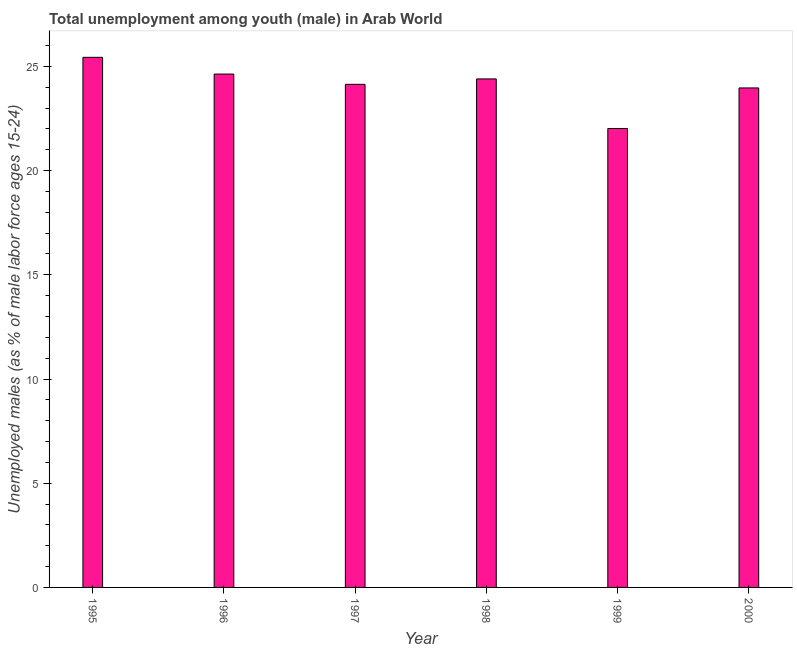What is the title of the graph?
Your response must be concise. Total unemployment among youth (male) in Arab World. What is the label or title of the Y-axis?
Offer a very short reply. Unemployed males (as % of male labor force ages 15-24). What is the unemployed male youth population in 1995?
Provide a short and direct response. 25.44. Across all years, what is the maximum unemployed male youth population?
Keep it short and to the point. 25.44. Across all years, what is the minimum unemployed male youth population?
Offer a terse response. 22.02. What is the sum of the unemployed male youth population?
Ensure brevity in your answer.  144.6. What is the difference between the unemployed male youth population in 1996 and 1999?
Make the answer very short. 2.61. What is the average unemployed male youth population per year?
Give a very brief answer. 24.1. What is the median unemployed male youth population?
Offer a terse response. 24.27. What is the ratio of the unemployed male youth population in 1995 to that in 1997?
Keep it short and to the point. 1.05. Is the difference between the unemployed male youth population in 1996 and 1997 greater than the difference between any two years?
Your answer should be very brief. No. What is the difference between the highest and the second highest unemployed male youth population?
Keep it short and to the point. 0.8. What is the difference between the highest and the lowest unemployed male youth population?
Provide a short and direct response. 3.42. In how many years, is the unemployed male youth population greater than the average unemployed male youth population taken over all years?
Your answer should be compact. 4. How many bars are there?
Your answer should be very brief. 6. What is the difference between two consecutive major ticks on the Y-axis?
Provide a short and direct response. 5. Are the values on the major ticks of Y-axis written in scientific E-notation?
Ensure brevity in your answer.  No. What is the Unemployed males (as % of male labor force ages 15-24) of 1995?
Provide a short and direct response. 25.44. What is the Unemployed males (as % of male labor force ages 15-24) in 1996?
Keep it short and to the point. 24.63. What is the Unemployed males (as % of male labor force ages 15-24) of 1997?
Give a very brief answer. 24.14. What is the Unemployed males (as % of male labor force ages 15-24) of 1998?
Make the answer very short. 24.4. What is the Unemployed males (as % of male labor force ages 15-24) in 1999?
Provide a short and direct response. 22.02. What is the Unemployed males (as % of male labor force ages 15-24) in 2000?
Make the answer very short. 23.97. What is the difference between the Unemployed males (as % of male labor force ages 15-24) in 1995 and 1996?
Ensure brevity in your answer.  0.8. What is the difference between the Unemployed males (as % of male labor force ages 15-24) in 1995 and 1997?
Provide a short and direct response. 1.3. What is the difference between the Unemployed males (as % of male labor force ages 15-24) in 1995 and 1998?
Offer a very short reply. 1.04. What is the difference between the Unemployed males (as % of male labor force ages 15-24) in 1995 and 1999?
Offer a very short reply. 3.42. What is the difference between the Unemployed males (as % of male labor force ages 15-24) in 1995 and 2000?
Your answer should be compact. 1.47. What is the difference between the Unemployed males (as % of male labor force ages 15-24) in 1996 and 1997?
Offer a terse response. 0.49. What is the difference between the Unemployed males (as % of male labor force ages 15-24) in 1996 and 1998?
Provide a short and direct response. 0.23. What is the difference between the Unemployed males (as % of male labor force ages 15-24) in 1996 and 1999?
Ensure brevity in your answer.  2.61. What is the difference between the Unemployed males (as % of male labor force ages 15-24) in 1996 and 2000?
Ensure brevity in your answer.  0.66. What is the difference between the Unemployed males (as % of male labor force ages 15-24) in 1997 and 1998?
Your response must be concise. -0.26. What is the difference between the Unemployed males (as % of male labor force ages 15-24) in 1997 and 1999?
Keep it short and to the point. 2.12. What is the difference between the Unemployed males (as % of male labor force ages 15-24) in 1997 and 2000?
Offer a very short reply. 0.17. What is the difference between the Unemployed males (as % of male labor force ages 15-24) in 1998 and 1999?
Make the answer very short. 2.38. What is the difference between the Unemployed males (as % of male labor force ages 15-24) in 1998 and 2000?
Offer a very short reply. 0.43. What is the difference between the Unemployed males (as % of male labor force ages 15-24) in 1999 and 2000?
Keep it short and to the point. -1.95. What is the ratio of the Unemployed males (as % of male labor force ages 15-24) in 1995 to that in 1996?
Your answer should be very brief. 1.03. What is the ratio of the Unemployed males (as % of male labor force ages 15-24) in 1995 to that in 1997?
Give a very brief answer. 1.05. What is the ratio of the Unemployed males (as % of male labor force ages 15-24) in 1995 to that in 1998?
Offer a very short reply. 1.04. What is the ratio of the Unemployed males (as % of male labor force ages 15-24) in 1995 to that in 1999?
Offer a terse response. 1.16. What is the ratio of the Unemployed males (as % of male labor force ages 15-24) in 1995 to that in 2000?
Your response must be concise. 1.06. What is the ratio of the Unemployed males (as % of male labor force ages 15-24) in 1996 to that in 1997?
Your answer should be very brief. 1.02. What is the ratio of the Unemployed males (as % of male labor force ages 15-24) in 1996 to that in 1999?
Provide a succinct answer. 1.12. What is the ratio of the Unemployed males (as % of male labor force ages 15-24) in 1996 to that in 2000?
Your response must be concise. 1.03. What is the ratio of the Unemployed males (as % of male labor force ages 15-24) in 1997 to that in 1998?
Keep it short and to the point. 0.99. What is the ratio of the Unemployed males (as % of male labor force ages 15-24) in 1997 to that in 1999?
Offer a very short reply. 1.1. What is the ratio of the Unemployed males (as % of male labor force ages 15-24) in 1997 to that in 2000?
Provide a succinct answer. 1.01. What is the ratio of the Unemployed males (as % of male labor force ages 15-24) in 1998 to that in 1999?
Provide a succinct answer. 1.11. What is the ratio of the Unemployed males (as % of male labor force ages 15-24) in 1999 to that in 2000?
Make the answer very short. 0.92. 